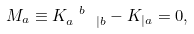<formula> <loc_0><loc_0><loc_500><loc_500>M _ { a } \equiv K _ { a \ \ | b } ^ { \ b } - K _ { | a } = 0 ,</formula> 